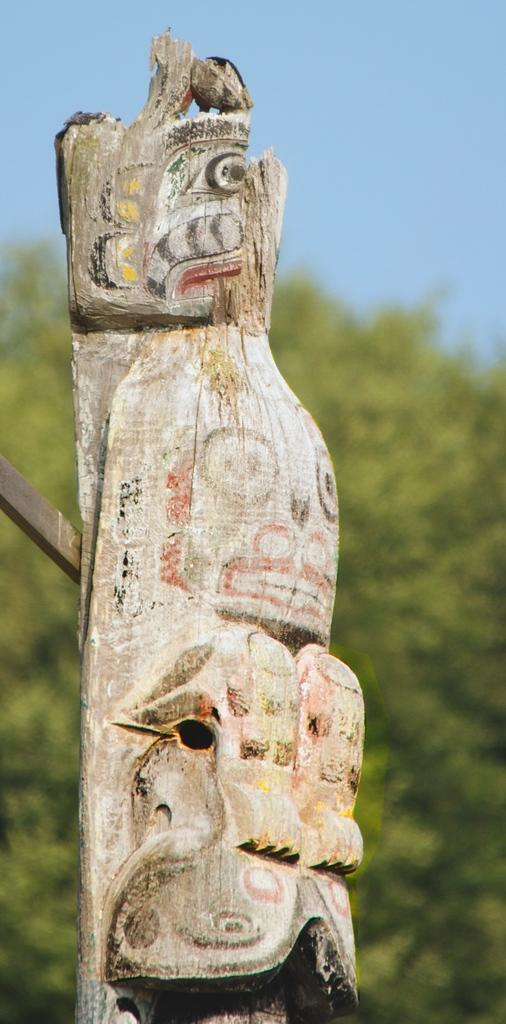What object is the main subject of the image? There is a wooden block in the image. Can you describe the wooden block in more detail? The wooden block is shaped and chiseled. What can be seen in the background of the image? There are trees in the background of the image. What is visible at the top of the image? The sky is visible at the top of the image. How would you describe the background of the image? The background is blurred. What type of ink is used to color the chain in the image? There is no chain or ink present in the image; it features a wooden block and a blurred background. What stage of development can be observed in the image? The image does not depict any developmental stages or processes; it is a static image of a wooden block. 